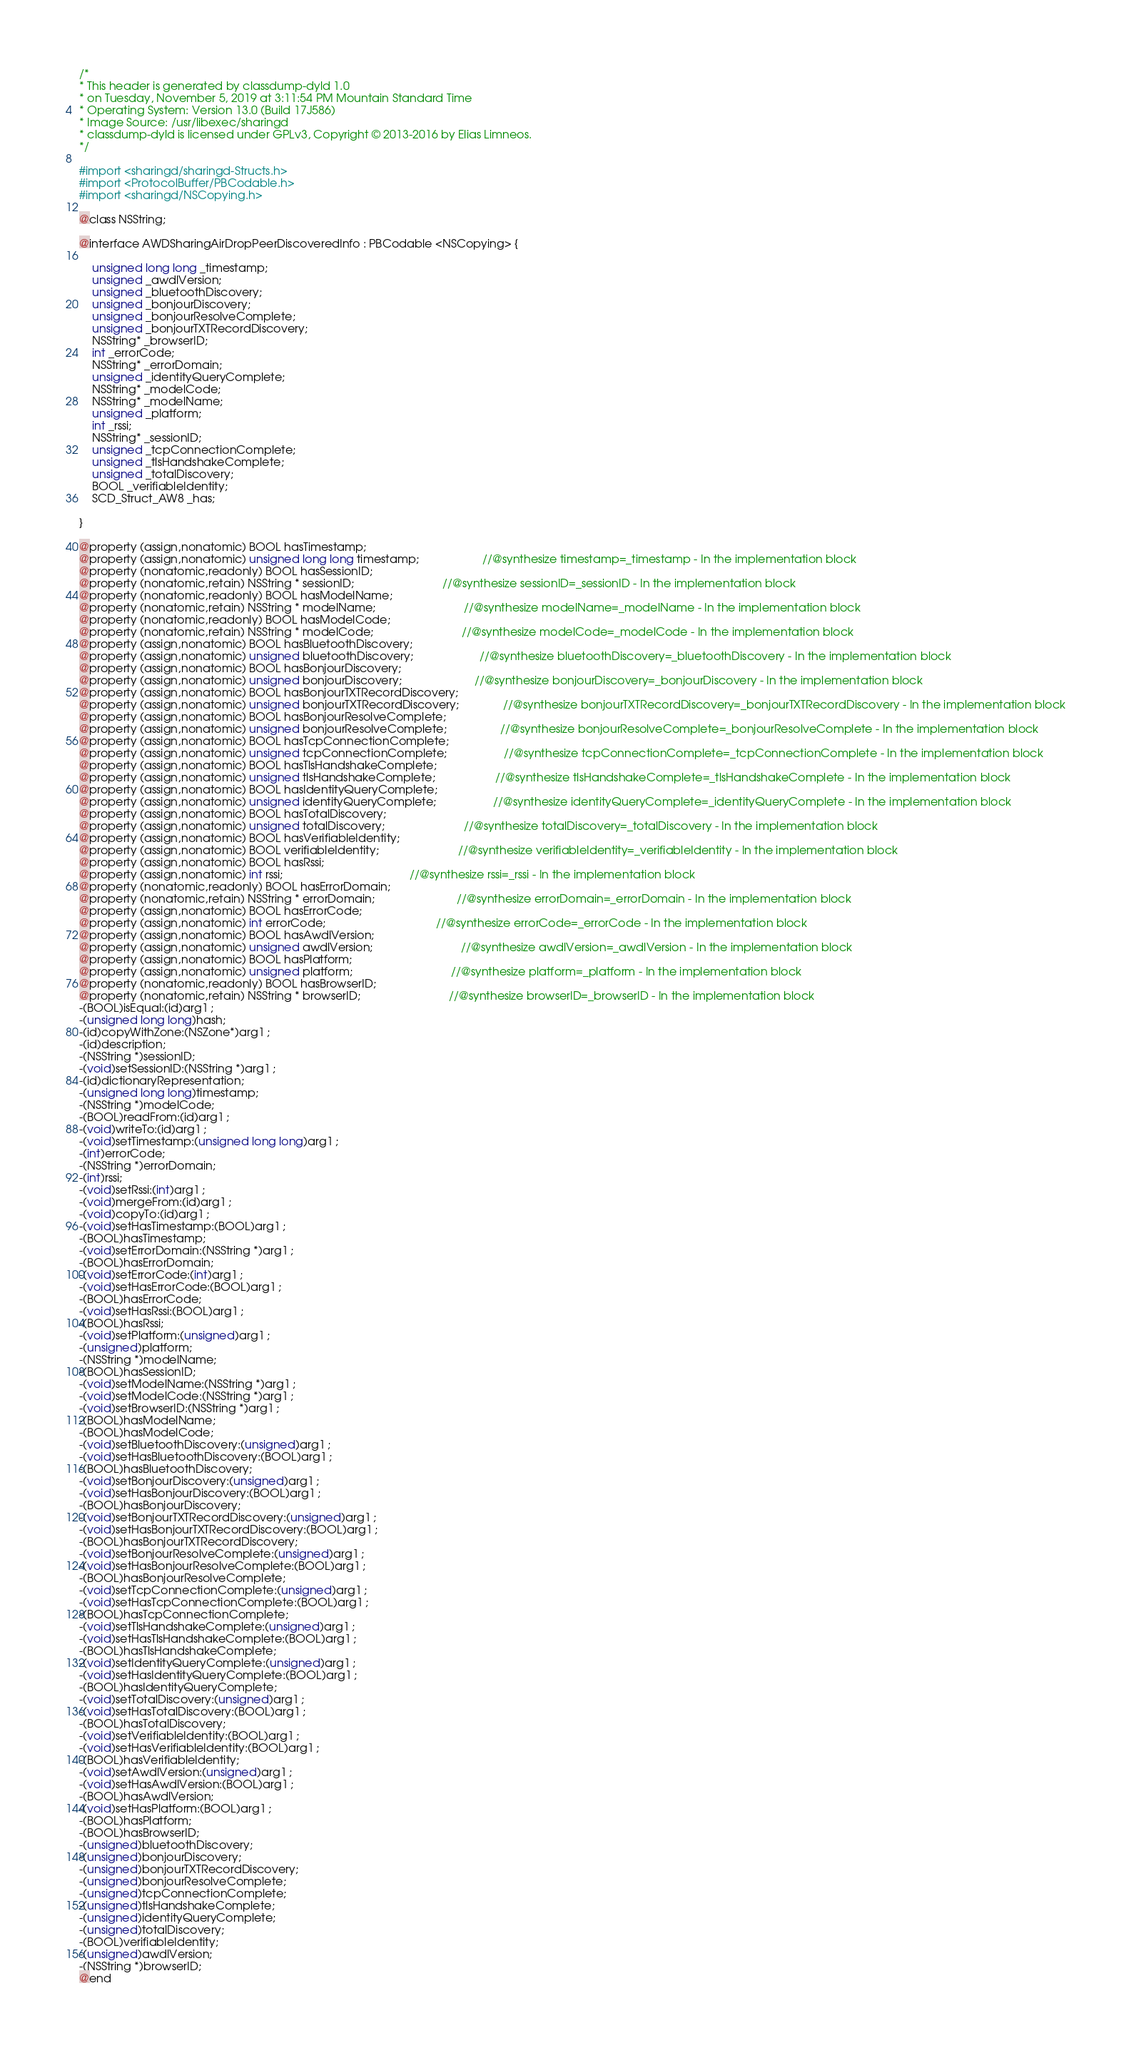Convert code to text. <code><loc_0><loc_0><loc_500><loc_500><_C_>/*
* This header is generated by classdump-dyld 1.0
* on Tuesday, November 5, 2019 at 3:11:54 PM Mountain Standard Time
* Operating System: Version 13.0 (Build 17J586)
* Image Source: /usr/libexec/sharingd
* classdump-dyld is licensed under GPLv3, Copyright © 2013-2016 by Elias Limneos.
*/

#import <sharingd/sharingd-Structs.h>
#import <ProtocolBuffer/PBCodable.h>
#import <sharingd/NSCopying.h>

@class NSString;

@interface AWDSharingAirDropPeerDiscoveredInfo : PBCodable <NSCopying> {

	unsigned long long _timestamp;
	unsigned _awdlVersion;
	unsigned _bluetoothDiscovery;
	unsigned _bonjourDiscovery;
	unsigned _bonjourResolveComplete;
	unsigned _bonjourTXTRecordDiscovery;
	NSString* _browserID;
	int _errorCode;
	NSString* _errorDomain;
	unsigned _identityQueryComplete;
	NSString* _modelCode;
	NSString* _modelName;
	unsigned _platform;
	int _rssi;
	NSString* _sessionID;
	unsigned _tcpConnectionComplete;
	unsigned _tlsHandshakeComplete;
	unsigned _totalDiscovery;
	BOOL _verifiableIdentity;
	SCD_Struct_AW8 _has;

}

@property (assign,nonatomic) BOOL hasTimestamp; 
@property (assign,nonatomic) unsigned long long timestamp;                    //@synthesize timestamp=_timestamp - In the implementation block
@property (nonatomic,readonly) BOOL hasSessionID; 
@property (nonatomic,retain) NSString * sessionID;                            //@synthesize sessionID=_sessionID - In the implementation block
@property (nonatomic,readonly) BOOL hasModelName; 
@property (nonatomic,retain) NSString * modelName;                            //@synthesize modelName=_modelName - In the implementation block
@property (nonatomic,readonly) BOOL hasModelCode; 
@property (nonatomic,retain) NSString * modelCode;                            //@synthesize modelCode=_modelCode - In the implementation block
@property (assign,nonatomic) BOOL hasBluetoothDiscovery; 
@property (assign,nonatomic) unsigned bluetoothDiscovery;                     //@synthesize bluetoothDiscovery=_bluetoothDiscovery - In the implementation block
@property (assign,nonatomic) BOOL hasBonjourDiscovery; 
@property (assign,nonatomic) unsigned bonjourDiscovery;                       //@synthesize bonjourDiscovery=_bonjourDiscovery - In the implementation block
@property (assign,nonatomic) BOOL hasBonjourTXTRecordDiscovery; 
@property (assign,nonatomic) unsigned bonjourTXTRecordDiscovery;              //@synthesize bonjourTXTRecordDiscovery=_bonjourTXTRecordDiscovery - In the implementation block
@property (assign,nonatomic) BOOL hasBonjourResolveComplete; 
@property (assign,nonatomic) unsigned bonjourResolveComplete;                 //@synthesize bonjourResolveComplete=_bonjourResolveComplete - In the implementation block
@property (assign,nonatomic) BOOL hasTcpConnectionComplete; 
@property (assign,nonatomic) unsigned tcpConnectionComplete;                  //@synthesize tcpConnectionComplete=_tcpConnectionComplete - In the implementation block
@property (assign,nonatomic) BOOL hasTlsHandshakeComplete; 
@property (assign,nonatomic) unsigned tlsHandshakeComplete;                   //@synthesize tlsHandshakeComplete=_tlsHandshakeComplete - In the implementation block
@property (assign,nonatomic) BOOL hasIdentityQueryComplete; 
@property (assign,nonatomic) unsigned identityQueryComplete;                  //@synthesize identityQueryComplete=_identityQueryComplete - In the implementation block
@property (assign,nonatomic) BOOL hasTotalDiscovery; 
@property (assign,nonatomic) unsigned totalDiscovery;                         //@synthesize totalDiscovery=_totalDiscovery - In the implementation block
@property (assign,nonatomic) BOOL hasVerifiableIdentity; 
@property (assign,nonatomic) BOOL verifiableIdentity;                         //@synthesize verifiableIdentity=_verifiableIdentity - In the implementation block
@property (assign,nonatomic) BOOL hasRssi; 
@property (assign,nonatomic) int rssi;                                        //@synthesize rssi=_rssi - In the implementation block
@property (nonatomic,readonly) BOOL hasErrorDomain; 
@property (nonatomic,retain) NSString * errorDomain;                          //@synthesize errorDomain=_errorDomain - In the implementation block
@property (assign,nonatomic) BOOL hasErrorCode; 
@property (assign,nonatomic) int errorCode;                                   //@synthesize errorCode=_errorCode - In the implementation block
@property (assign,nonatomic) BOOL hasAwdlVersion; 
@property (assign,nonatomic) unsigned awdlVersion;                            //@synthesize awdlVersion=_awdlVersion - In the implementation block
@property (assign,nonatomic) BOOL hasPlatform; 
@property (assign,nonatomic) unsigned platform;                               //@synthesize platform=_platform - In the implementation block
@property (nonatomic,readonly) BOOL hasBrowserID; 
@property (nonatomic,retain) NSString * browserID;                            //@synthesize browserID=_browserID - In the implementation block
-(BOOL)isEqual:(id)arg1 ;
-(unsigned long long)hash;
-(id)copyWithZone:(NSZone*)arg1 ;
-(id)description;
-(NSString *)sessionID;
-(void)setSessionID:(NSString *)arg1 ;
-(id)dictionaryRepresentation;
-(unsigned long long)timestamp;
-(NSString *)modelCode;
-(BOOL)readFrom:(id)arg1 ;
-(void)writeTo:(id)arg1 ;
-(void)setTimestamp:(unsigned long long)arg1 ;
-(int)errorCode;
-(NSString *)errorDomain;
-(int)rssi;
-(void)setRssi:(int)arg1 ;
-(void)mergeFrom:(id)arg1 ;
-(void)copyTo:(id)arg1 ;
-(void)setHasTimestamp:(BOOL)arg1 ;
-(BOOL)hasTimestamp;
-(void)setErrorDomain:(NSString *)arg1 ;
-(BOOL)hasErrorDomain;
-(void)setErrorCode:(int)arg1 ;
-(void)setHasErrorCode:(BOOL)arg1 ;
-(BOOL)hasErrorCode;
-(void)setHasRssi:(BOOL)arg1 ;
-(BOOL)hasRssi;
-(void)setPlatform:(unsigned)arg1 ;
-(unsigned)platform;
-(NSString *)modelName;
-(BOOL)hasSessionID;
-(void)setModelName:(NSString *)arg1 ;
-(void)setModelCode:(NSString *)arg1 ;
-(void)setBrowserID:(NSString *)arg1 ;
-(BOOL)hasModelName;
-(BOOL)hasModelCode;
-(void)setBluetoothDiscovery:(unsigned)arg1 ;
-(void)setHasBluetoothDiscovery:(BOOL)arg1 ;
-(BOOL)hasBluetoothDiscovery;
-(void)setBonjourDiscovery:(unsigned)arg1 ;
-(void)setHasBonjourDiscovery:(BOOL)arg1 ;
-(BOOL)hasBonjourDiscovery;
-(void)setBonjourTXTRecordDiscovery:(unsigned)arg1 ;
-(void)setHasBonjourTXTRecordDiscovery:(BOOL)arg1 ;
-(BOOL)hasBonjourTXTRecordDiscovery;
-(void)setBonjourResolveComplete:(unsigned)arg1 ;
-(void)setHasBonjourResolveComplete:(BOOL)arg1 ;
-(BOOL)hasBonjourResolveComplete;
-(void)setTcpConnectionComplete:(unsigned)arg1 ;
-(void)setHasTcpConnectionComplete:(BOOL)arg1 ;
-(BOOL)hasTcpConnectionComplete;
-(void)setTlsHandshakeComplete:(unsigned)arg1 ;
-(void)setHasTlsHandshakeComplete:(BOOL)arg1 ;
-(BOOL)hasTlsHandshakeComplete;
-(void)setIdentityQueryComplete:(unsigned)arg1 ;
-(void)setHasIdentityQueryComplete:(BOOL)arg1 ;
-(BOOL)hasIdentityQueryComplete;
-(void)setTotalDiscovery:(unsigned)arg1 ;
-(void)setHasTotalDiscovery:(BOOL)arg1 ;
-(BOOL)hasTotalDiscovery;
-(void)setVerifiableIdentity:(BOOL)arg1 ;
-(void)setHasVerifiableIdentity:(BOOL)arg1 ;
-(BOOL)hasVerifiableIdentity;
-(void)setAwdlVersion:(unsigned)arg1 ;
-(void)setHasAwdlVersion:(BOOL)arg1 ;
-(BOOL)hasAwdlVersion;
-(void)setHasPlatform:(BOOL)arg1 ;
-(BOOL)hasPlatform;
-(BOOL)hasBrowserID;
-(unsigned)bluetoothDiscovery;
-(unsigned)bonjourDiscovery;
-(unsigned)bonjourTXTRecordDiscovery;
-(unsigned)bonjourResolveComplete;
-(unsigned)tcpConnectionComplete;
-(unsigned)tlsHandshakeComplete;
-(unsigned)identityQueryComplete;
-(unsigned)totalDiscovery;
-(BOOL)verifiableIdentity;
-(unsigned)awdlVersion;
-(NSString *)browserID;
@end

</code> 